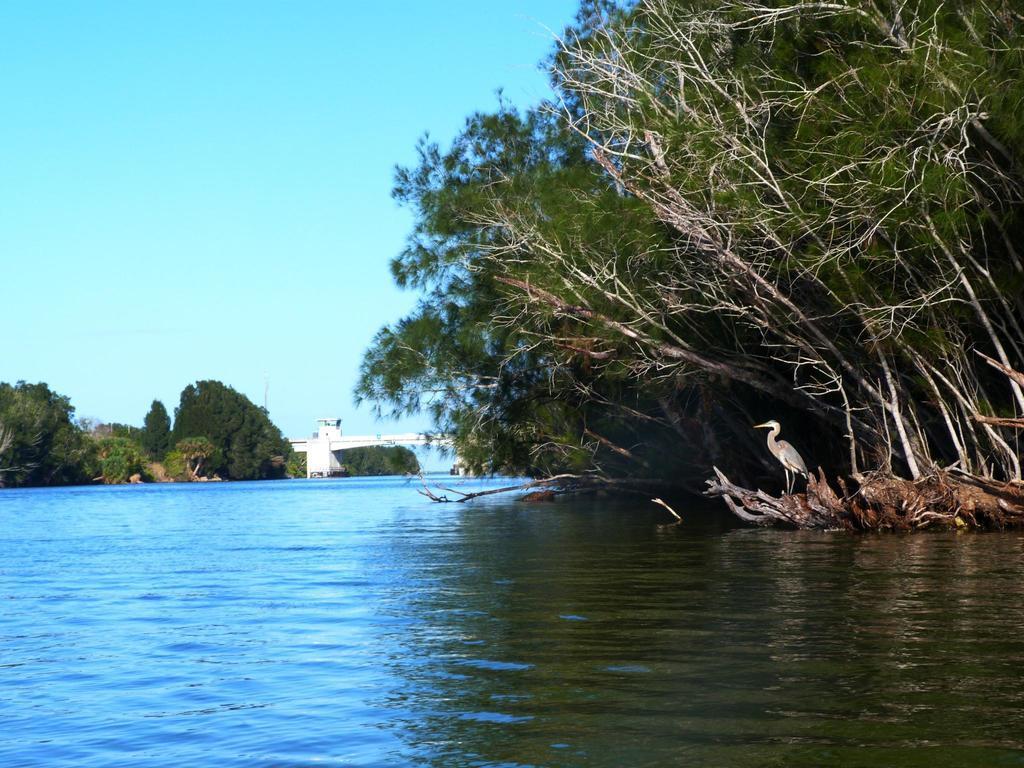In one or two sentences, can you explain what this image depicts? In this image in front there is water and we can see a crane at the root of a tree. At the center of the image there is a bridge. In the background there are trees and sky. 